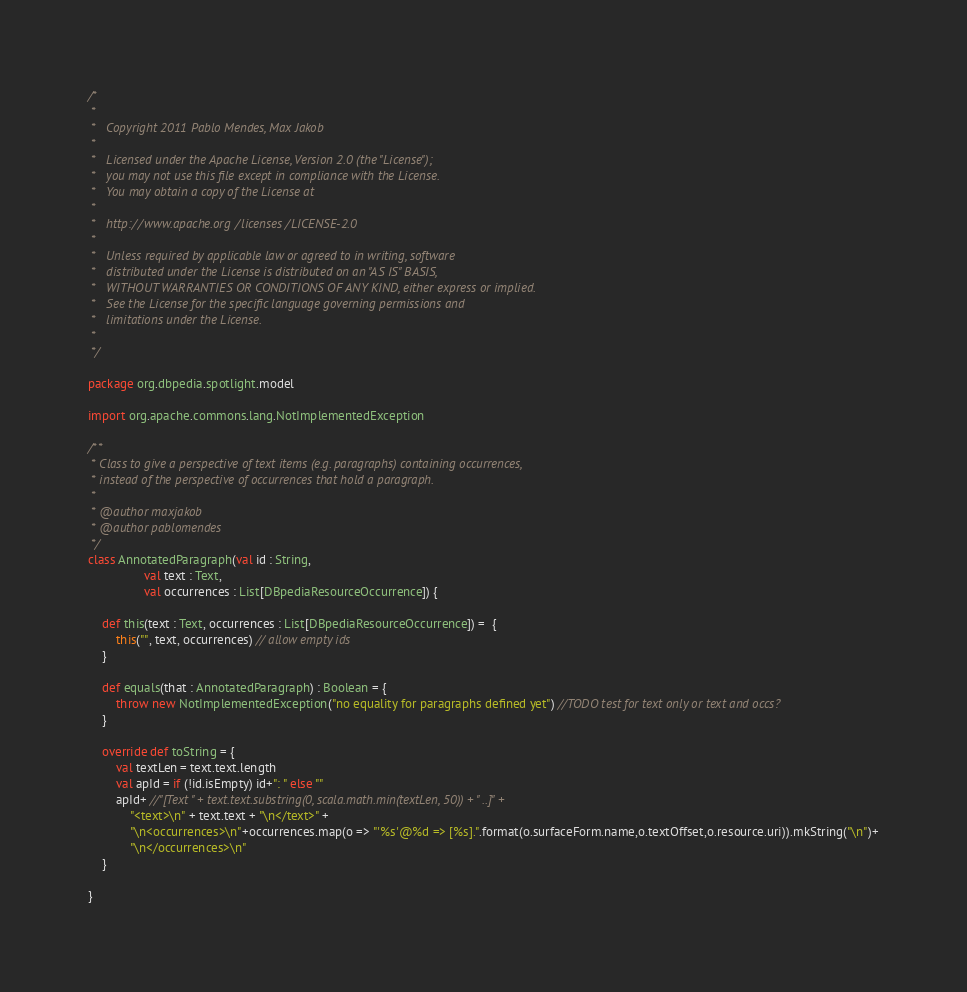<code> <loc_0><loc_0><loc_500><loc_500><_Scala_>/*
 *
 *   Copyright 2011 Pablo Mendes, Max Jakob
 *
 *   Licensed under the Apache License, Version 2.0 (the "License");
 *   you may not use this file except in compliance with the License.
 *   You may obtain a copy of the License at
 *
 *   http://www.apache.org/licenses/LICENSE-2.0
 *
 *   Unless required by applicable law or agreed to in writing, software
 *   distributed under the License is distributed on an "AS IS" BASIS,
 *   WITHOUT WARRANTIES OR CONDITIONS OF ANY KIND, either express or implied.
 *   See the License for the specific language governing permissions and
 *   limitations under the License.
 *
 */

package org.dbpedia.spotlight.model

import org.apache.commons.lang.NotImplementedException

/**
 * Class to give a perspective of text items (e.g. paragraphs) containing occurrences,
 * instead of the perspective of occurrences that hold a paragraph.
 *
 * @author maxjakob
 * @author pablomendes
 */
class AnnotatedParagraph(val id : String,
                val text : Text,
                val occurrences : List[DBpediaResourceOccurrence]) {

    def this(text : Text, occurrences : List[DBpediaResourceOccurrence]) =  {
        this("", text, occurrences) // allow empty ids
    }

    def equals(that : AnnotatedParagraph) : Boolean = {
        throw new NotImplementedException("no equality for paragraphs defined yet") //TODO test for text only or text and occs?
    }

    override def toString = {
        val textLen = text.text.length
        val apId = if (!id.isEmpty) id+": " else ""
        apId+ //"[Text " + text.text.substring(0, scala.math.min(textLen, 50)) + " ..]" +
            "<text>\n" + text.text + "\n</text>" +
            "\n<occurrences>\n"+occurrences.map(o => "'%s'@%d => [%s].".format(o.surfaceForm.name,o.textOffset,o.resource.uri)).mkString("\n")+
            "\n</occurrences>\n"
    }

}</code> 